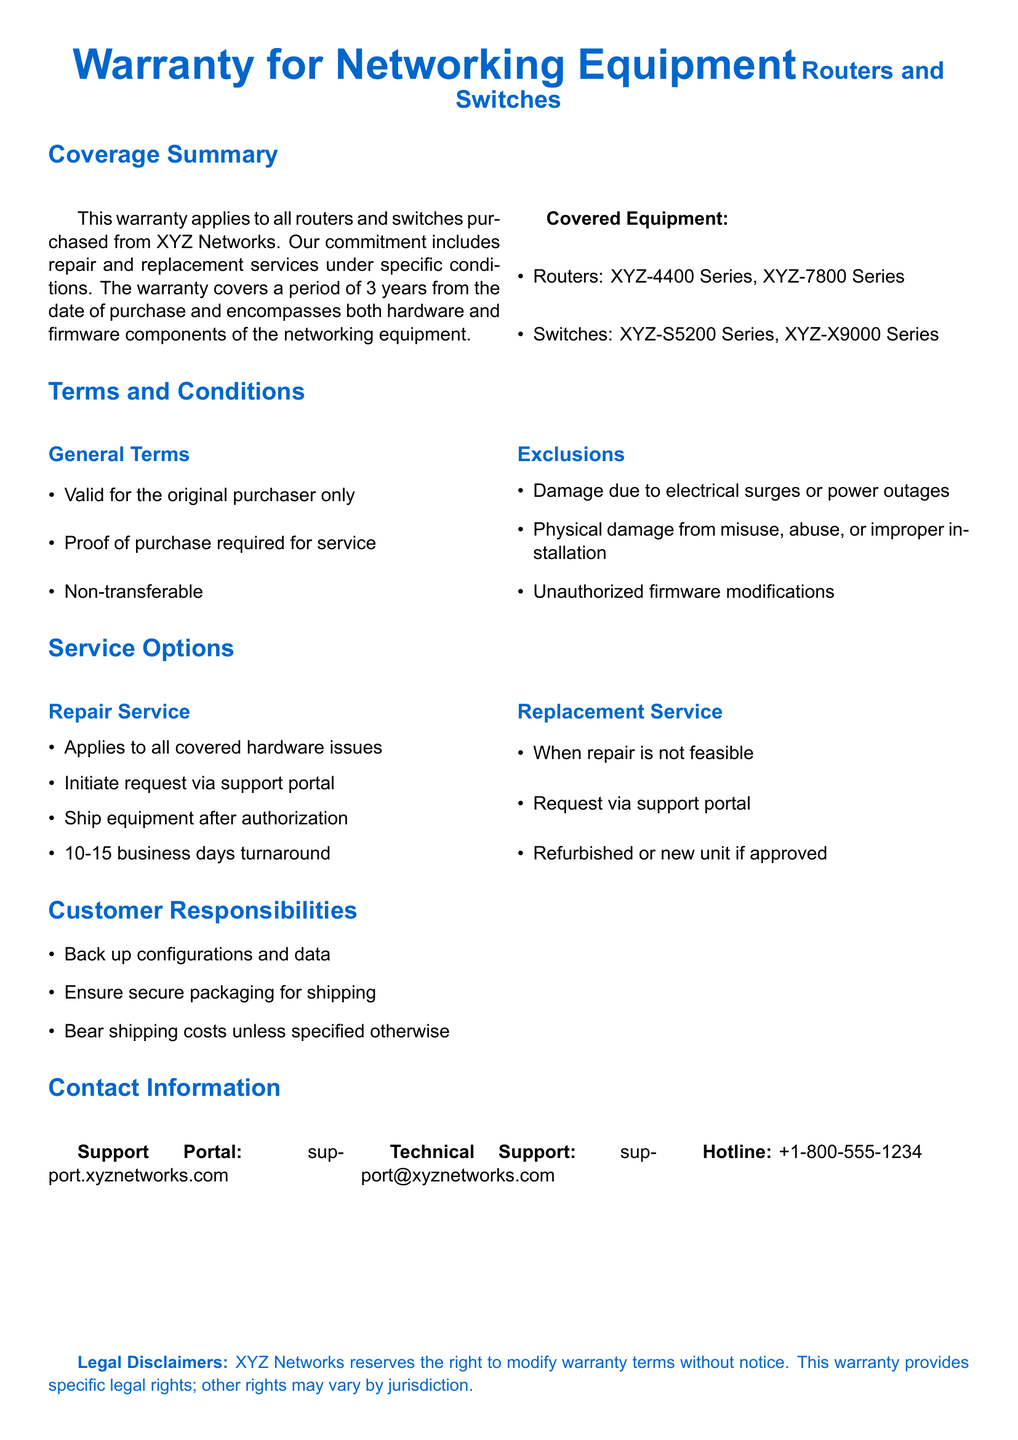What is the warranty period? The warranty period is specified as lasting for 3 years from the date of purchase.
Answer: 3 years What types of equipment are covered? The document lists two types of equipment specifically covered under the warranty: routers and switches.
Answer: Routers and switches Which router series is included? The document mentions specific router series that are covered, which are the XYZ-4400 Series and XYZ-7800 Series.
Answer: XYZ-4400 Series, XYZ-7800 Series What should a customer do to initiate repair service? The document states that to initiate repair service, a request must be made via the support portal.
Answer: Support portal What is the turnaround time for repair service? The turnaround time is specified to be between 10 and 15 business days once a request is authorized.
Answer: 10-15 business days What type of damage is excluded from the warranty? The document lists several exclusions, including damage due to electrical surges or power outages as one type of excluded damage.
Answer: Electrical surges Is the warranty transferable? The document clearly states that the warranty is non-transferable.
Answer: Non-transferable Where can customers find the support portal? The support portal's address is listed explicitly in the document.
Answer: support.xyznetworks.com What action is required from customers regarding configurations and data? Customers are required to back up their configurations and data before sending in the equipment for service.
Answer: Back up configurations and data 